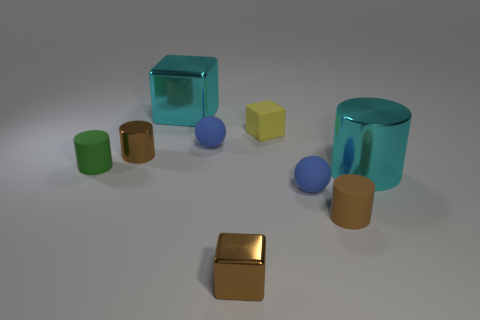Is the color of the tiny rubber block the same as the large shiny cube?
Ensure brevity in your answer.  No. Are there any brown metallic cubes that have the same size as the yellow object?
Give a very brief answer. Yes. How many large cyan objects are both on the left side of the large cyan metal cylinder and in front of the green rubber object?
Keep it short and to the point. 0. What number of tiny brown cubes are behind the yellow block?
Provide a succinct answer. 0. Is there a tiny blue shiny object that has the same shape as the tiny green rubber object?
Ensure brevity in your answer.  No. Does the tiny yellow matte object have the same shape as the cyan thing in front of the large metallic cube?
Provide a succinct answer. No. What number of balls are brown objects or big shiny objects?
Give a very brief answer. 0. There is a cyan object that is behind the tiny green matte thing; what is its shape?
Offer a very short reply. Cube. How many tiny green cylinders have the same material as the large cyan cube?
Provide a succinct answer. 0. Is the number of small brown blocks that are to the right of the small brown cube less than the number of large metal cylinders?
Provide a succinct answer. Yes. 